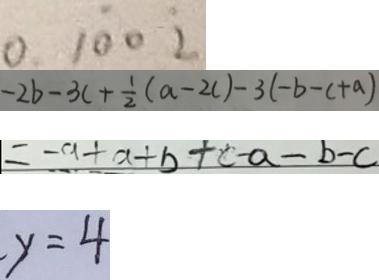<formula> <loc_0><loc_0><loc_500><loc_500>0 . 1 \dot { 0 } 0 \dot { 2 } 
 - 2 b - 3 c + \frac { 1 } { 2 } ( a - 2 c ) - 3 ( - b - c + a ) 
 = - a + a + b + c - a - b - c 
 - y = 4</formula> 